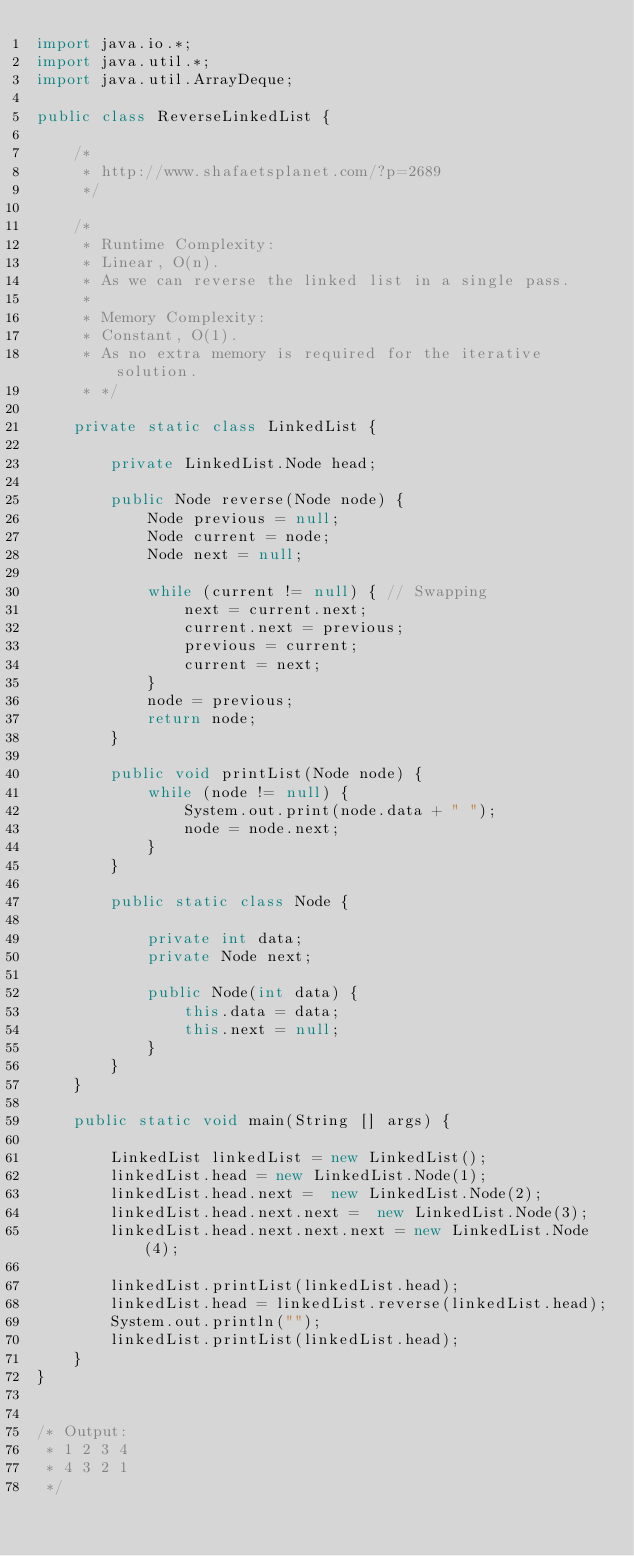Convert code to text. <code><loc_0><loc_0><loc_500><loc_500><_Java_>import java.io.*;
import java.util.*;
import java.util.ArrayDeque;

public class ReverseLinkedList {

    /*
     * http://www.shafaetsplanet.com/?p=2689
     */
    
    /*
     * Runtime Complexity:
     * Linear, O(n).
     * As we can reverse the linked list in a single pass.
     *
     * Memory Complexity:
     * Constant, O(1).
     * As no extra memory is required for the iterative solution.
     * */

    private static class LinkedList {

        private LinkedList.Node head;
        
        public Node reverse(Node node) {
            Node previous = null;
            Node current = node;
            Node next = null;

            while (current != null) { // Swapping
                next = current.next; 
                current.next = previous; 
                previous = current; 
                current = next;
            }
            node = previous;
            return node;
        }

        public void printList(Node node) {
            while (node != null) {
                System.out.print(node.data + " ");
                node = node.next;
            }
        }

        public static class Node {

            private int data;
            private Node next;

            public Node(int data) {
                this.data = data;
                this.next = null;
            }
        }
    }

    public static void main(String [] args) {

        LinkedList linkedList = new LinkedList();
        linkedList.head = new LinkedList.Node(1);
        linkedList.head.next =  new LinkedList.Node(2);
        linkedList.head.next.next =  new LinkedList.Node(3);
        linkedList.head.next.next.next = new LinkedList.Node(4);

        linkedList.printList(linkedList.head);
        linkedList.head = linkedList.reverse(linkedList.head);
        System.out.println("");
        linkedList.printList(linkedList.head);
    }
}


/* Output: 
 * 1 2 3 4
 * 4 3 2 1
 */
</code> 